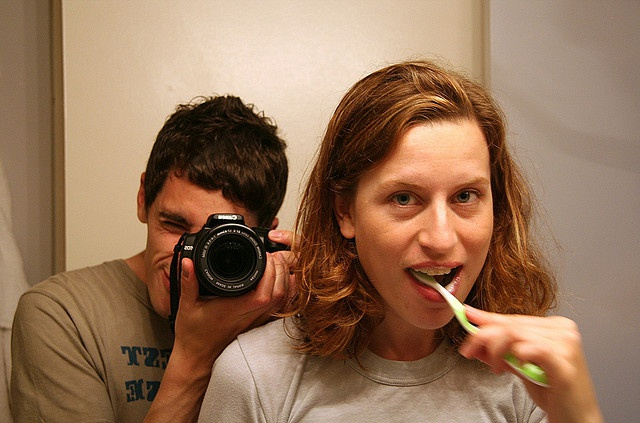Describe the objects in this image and their specific colors. I can see people in gray, maroon, brown, and black tones, people in gray, black, and maroon tones, and toothbrush in gray, maroon, brown, khaki, and ivory tones in this image. 